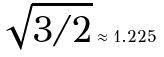<formula> <loc_0><loc_0><loc_500><loc_500>\sqrt { 3 / 2 } \approx 1 . 2 2 5</formula> 